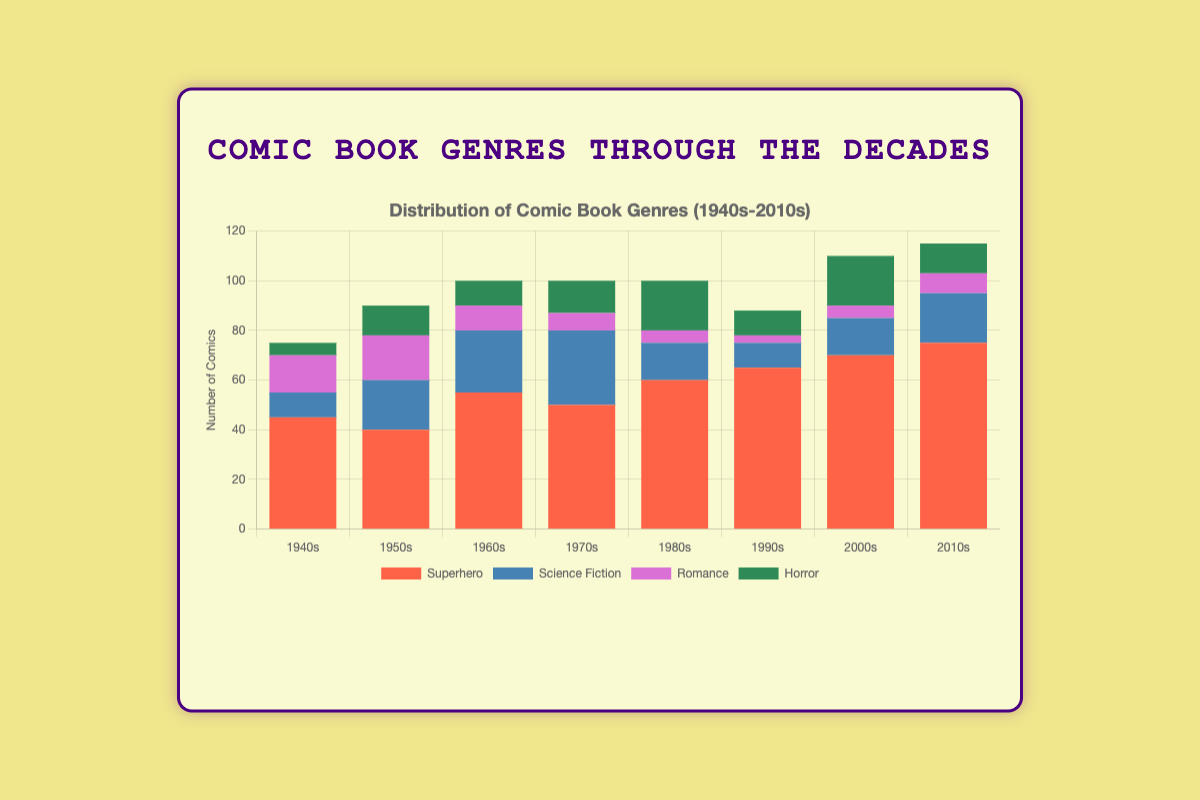Which decade has the highest count of superhero comics? The decade with the highest count of superhero comics is identified by the tallest red bar representing superheroes across all decades. In the 2010s, the red bar reaches its maximum height, representing 75 comics.
Answer: 2010s How many horror comics were there in the 1950s and 1960s combined? To determine the total count of horror comics in the 1950s and 1960s, sum the heights of the green bars for these two decades. The green bar for the 1950s represents 12 comics, and for the 1960s, it represents 10 comics. Therefore, the total is 12 + 10 = 22 comics.
Answer: 22 Which genre showed the most significant increase from the 1940s to the 1950s? Compare the height differences for each genre between the 1940s and the 1950s. The blue bar for Science Fiction increases from 10 in the 1940s to 20 in the 1950s, which is an increase of 10. This increase is more than the change in any other genre.
Answer: Science Fiction How has the count of romance comics changed from the 1980s to the 2000s? Observe the height of the purple bars for romance comics in the 1980s and the 2000s. In the 1980s, the count is 5, and in the 2000s, it is also 5. There is no change in the count.
Answer: No change What is the difference in superhero comic counts between the 1970s and 1980s? Subtract the count of superhero comics in the 1970s (50) from the count in the 1980s (60). The difference is 60 - 50 = 10 comics.
Answer: 10 Which decade had the least number of science fiction comics? Identify the decade with the shortest blue bar representing science fiction comics. The shortest blue bar is in the 1940s with 10 comics.
Answer: 1940s In which decades did horror comics reach a count of at least 20? Check the height of green bars for horror comics meeting or exceeding the height representing 20 comics. In the 1980s and 2000s, the green bars reach 20 comics.
Answer: 1980s, 2000s How many total comics were published in the 1940s? Sum the heights of all bars in the 1940s. The counts are 45 (superhero) + 10 (science fiction) + 15 (romance) + 5 (horror), summing up to 75 comics.
Answer: 75 What is the average count of horror comics for the decades shown? Sum the count of horror comics for each decade and divide by the number of decades. The counts are 5, 12, 10, 13, 20, 10, 20, and 12. The total count is 102, divided by 8 decades, results in 102 / 8 = 12.75.
Answer: 12.75 